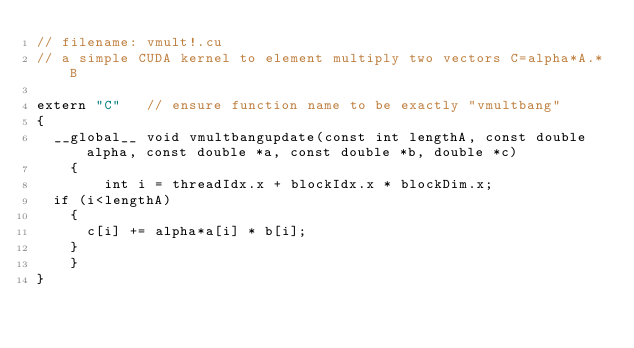Convert code to text. <code><loc_0><loc_0><loc_500><loc_500><_Cuda_>// filename: vmult!.cu
// a simple CUDA kernel to element multiply two vectors C=alpha*A.*B

extern "C"   // ensure function name to be exactly "vmultbang"
{
  __global__ void vmultbangupdate(const int lengthA, const double alpha, const double *a, const double *b, double *c)
    {
        int i = threadIdx.x + blockIdx.x * blockDim.x;
	if (i<lengthA)
	  {
	    c[i] += alpha*a[i] * b[i];
	  }	
    }
}</code> 